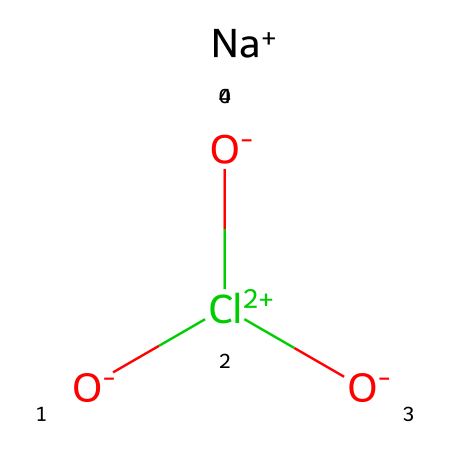What is the main constituent element in sodium chlorate? The main constituent element can be identified by looking at the SMILES representation. In the structure, sodium (Na), oxygen (O), and chlorine (Cl) are present, but sodium is the primary component based on its position.
Answer: sodium How many oxygen atoms are present in sodium chlorate? By analyzing the SMILES string, three oxygen atoms can be identified as they are explicitly stated in the structure (O- and two O in the Cl(=O)=O).
Answer: three What is the oxidation state of chlorine in sodium chlorate? To determine the oxidation state, we consider that sodium is +1, and the overall charge balance should equal zero. The three oxygen atoms contribute a total of -2 (two double-bonded to Cl and one negatively charged), leading to the conclusion that Cl must be +5 to balance the charges.
Answer: +5 Which type of chemical does sodium chlorate belong to? Sodium chlorate is classified according to its properties and uses. In this case, the presence of chlorine and its oxidizing characteristics indicate that it is an oxidizer, commonly used as a herbicide.
Answer: oxidizer What is the molecular formula of sodium chlorate? The molecular formula can be deduced by identifying the number of each type of atom in the substance. From the SMILES, we have one sodium (Na), one chlorine (Cl), and three oxygens (O), leading to the formula NaClO3.
Answer: NaClO3 